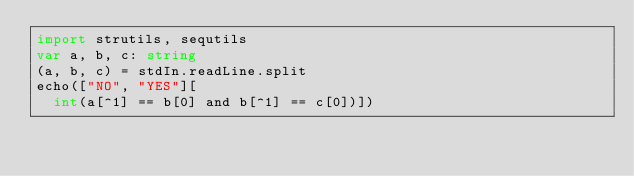<code> <loc_0><loc_0><loc_500><loc_500><_Nim_>import strutils, sequtils
var a, b, c: string
(a, b, c) = stdIn.readLine.split
echo(["NO", "YES"][
  int(a[^1] == b[0] and b[^1] == c[0])])
</code> 